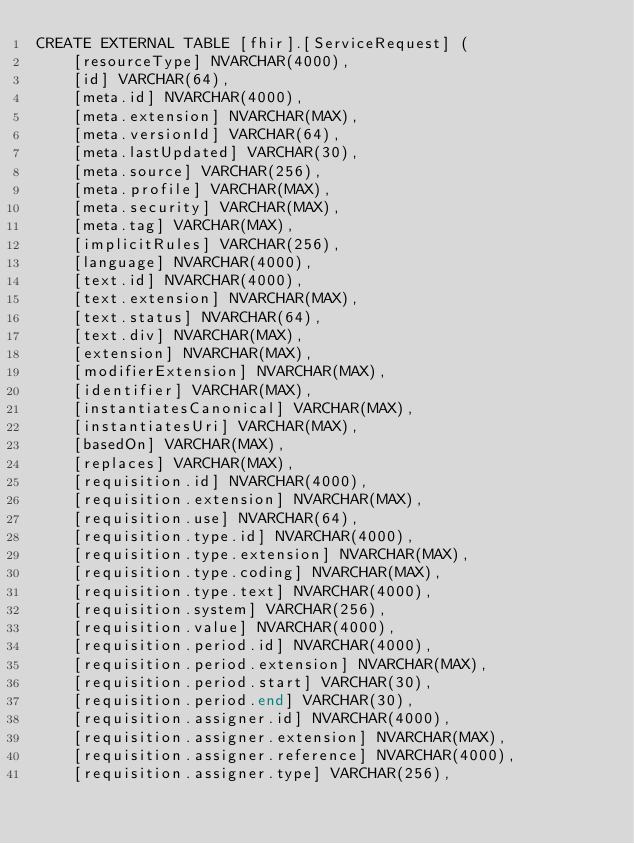Convert code to text. <code><loc_0><loc_0><loc_500><loc_500><_SQL_>CREATE EXTERNAL TABLE [fhir].[ServiceRequest] (
    [resourceType] NVARCHAR(4000),
    [id] VARCHAR(64),
    [meta.id] NVARCHAR(4000),
    [meta.extension] NVARCHAR(MAX),
    [meta.versionId] VARCHAR(64),
    [meta.lastUpdated] VARCHAR(30),
    [meta.source] VARCHAR(256),
    [meta.profile] VARCHAR(MAX),
    [meta.security] VARCHAR(MAX),
    [meta.tag] VARCHAR(MAX),
    [implicitRules] VARCHAR(256),
    [language] NVARCHAR(4000),
    [text.id] NVARCHAR(4000),
    [text.extension] NVARCHAR(MAX),
    [text.status] NVARCHAR(64),
    [text.div] NVARCHAR(MAX),
    [extension] NVARCHAR(MAX),
    [modifierExtension] NVARCHAR(MAX),
    [identifier] VARCHAR(MAX),
    [instantiatesCanonical] VARCHAR(MAX),
    [instantiatesUri] VARCHAR(MAX),
    [basedOn] VARCHAR(MAX),
    [replaces] VARCHAR(MAX),
    [requisition.id] NVARCHAR(4000),
    [requisition.extension] NVARCHAR(MAX),
    [requisition.use] NVARCHAR(64),
    [requisition.type.id] NVARCHAR(4000),
    [requisition.type.extension] NVARCHAR(MAX),
    [requisition.type.coding] NVARCHAR(MAX),
    [requisition.type.text] NVARCHAR(4000),
    [requisition.system] VARCHAR(256),
    [requisition.value] NVARCHAR(4000),
    [requisition.period.id] NVARCHAR(4000),
    [requisition.period.extension] NVARCHAR(MAX),
    [requisition.period.start] VARCHAR(30),
    [requisition.period.end] VARCHAR(30),
    [requisition.assigner.id] NVARCHAR(4000),
    [requisition.assigner.extension] NVARCHAR(MAX),
    [requisition.assigner.reference] NVARCHAR(4000),
    [requisition.assigner.type] VARCHAR(256),</code> 